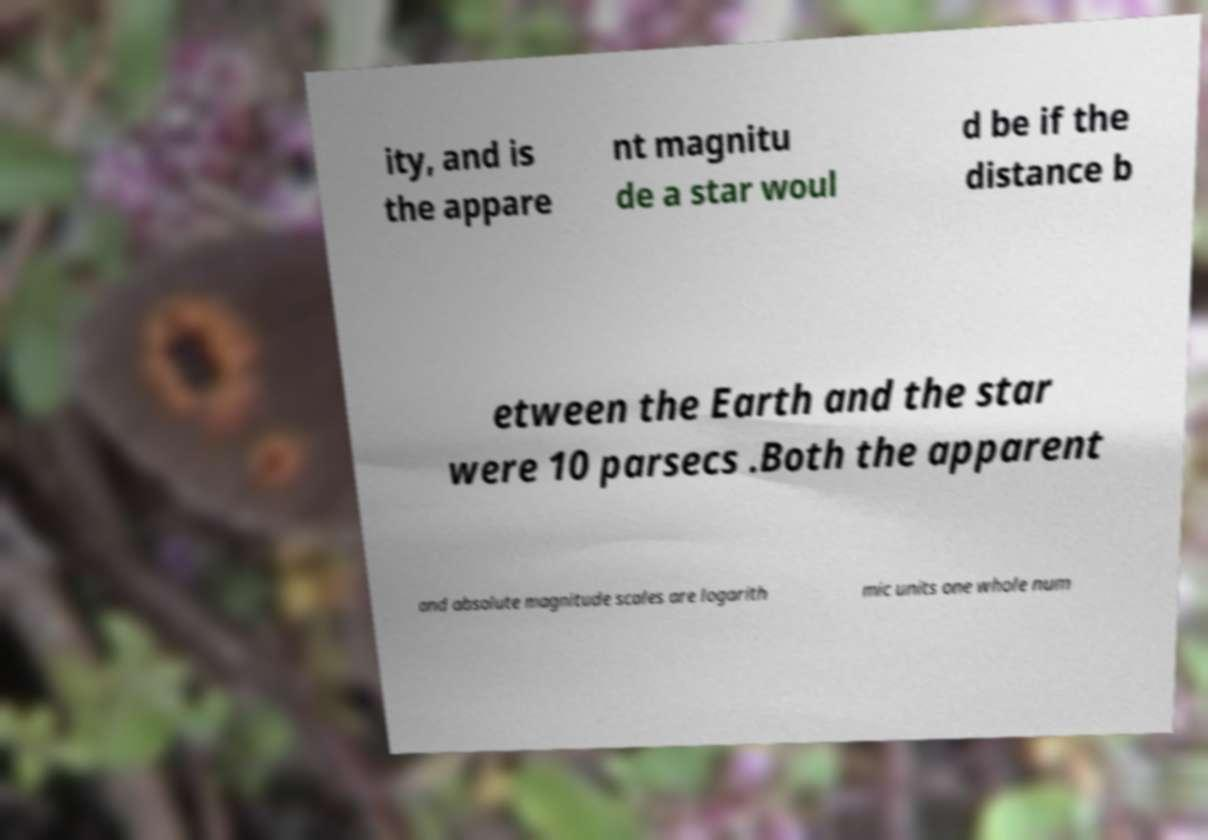Can you accurately transcribe the text from the provided image for me? ity, and is the appare nt magnitu de a star woul d be if the distance b etween the Earth and the star were 10 parsecs .Both the apparent and absolute magnitude scales are logarith mic units one whole num 